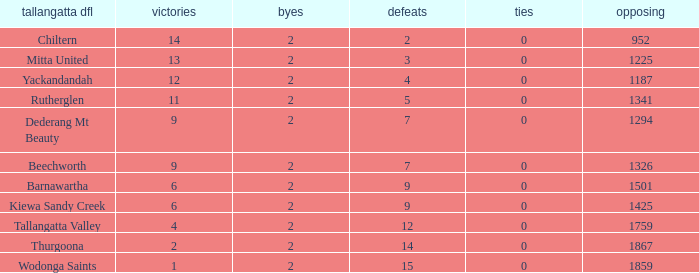What are the draws when wins are fwewer than 9 and byes fewer than 2? 0.0. 